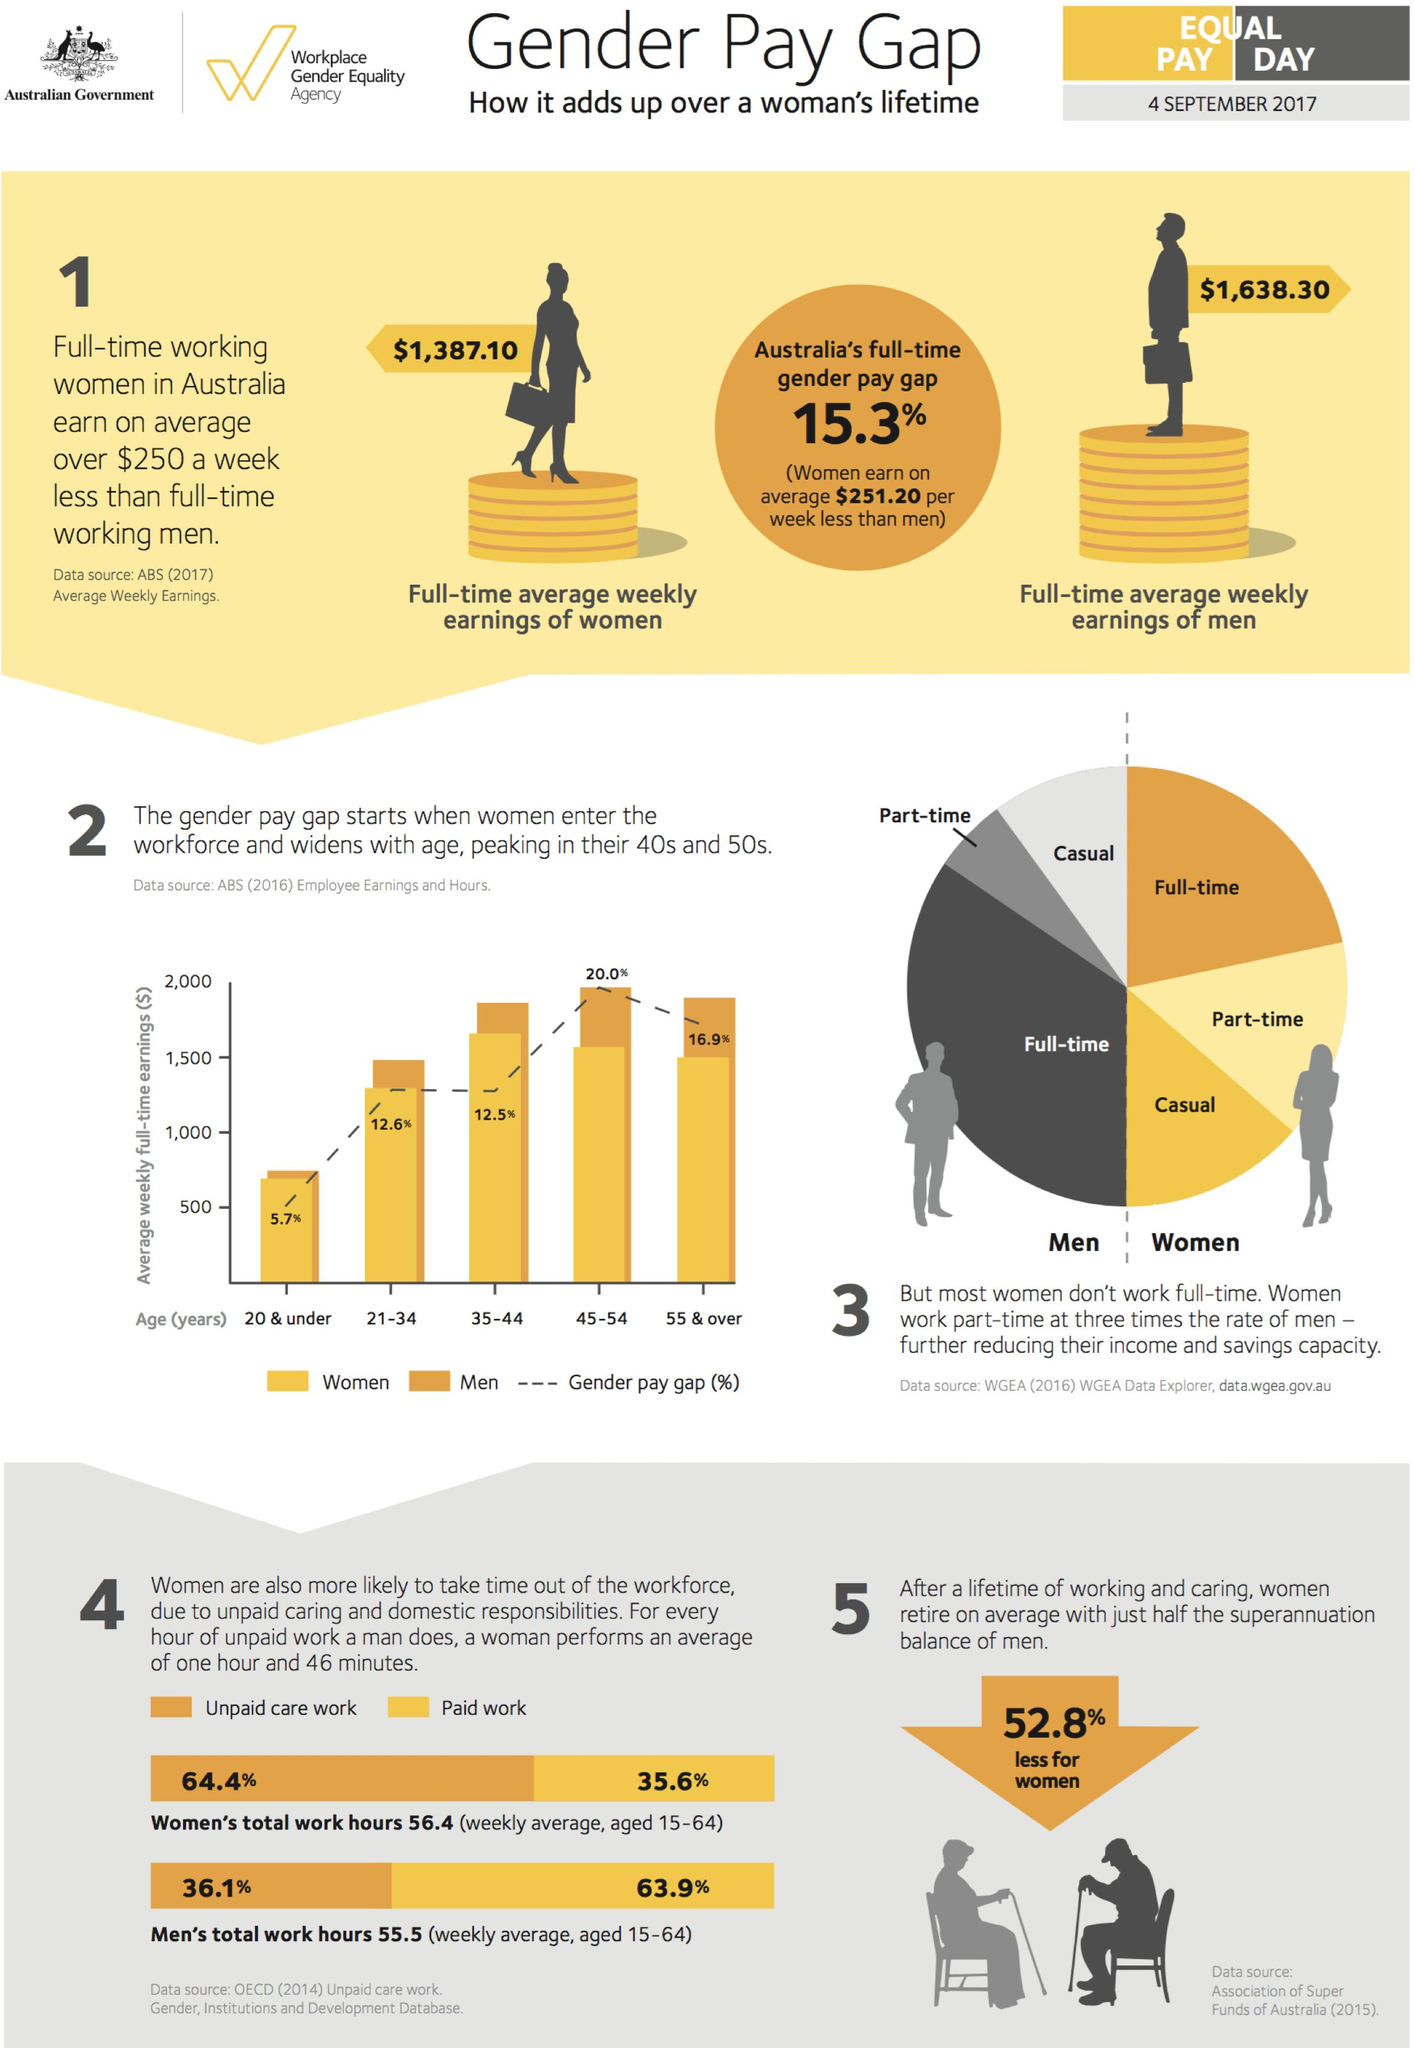Point out several critical features in this image. According to data from 4 September 2017, 64.4% of unpaid care work in Australia was done by women aged 15-64. According to data from September 4th, 2017, 63.9% of paid work in Australia is done by men aged 15-64. The gender pay gap for the 45-54 age group in Australia was 20.0% as of 4 September 2017. According to data from September 4th, 2017, women aged 15-64 in Australia account for 35.6% of paid work. On average, full-time working men in Australia earned $1,638.30 per week as of September 4th, 2017. 